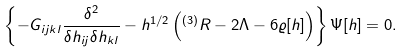Convert formula to latex. <formula><loc_0><loc_0><loc_500><loc_500>\left \{ - G _ { i j k l } \frac { \delta ^ { 2 } } { \delta h _ { i j } \delta h _ { k l } } - h ^ { 1 / 2 } \left ( { ^ { ( 3 ) } R } - 2 \Lambda - 6 \varrho [ h ] \right ) \right \} \Psi [ h ] = 0 .</formula> 